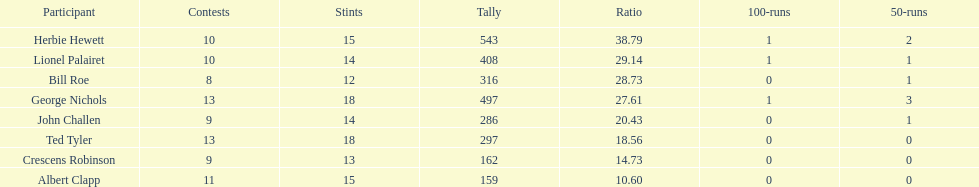Who are all of the players? Herbie Hewett, Lionel Palairet, Bill Roe, George Nichols, John Challen, Ted Tyler, Crescens Robinson, Albert Clapp. How many innings did they play in? 15, 14, 12, 18, 14, 18, 13, 15. Which player was in fewer than 13 innings? Bill Roe. 